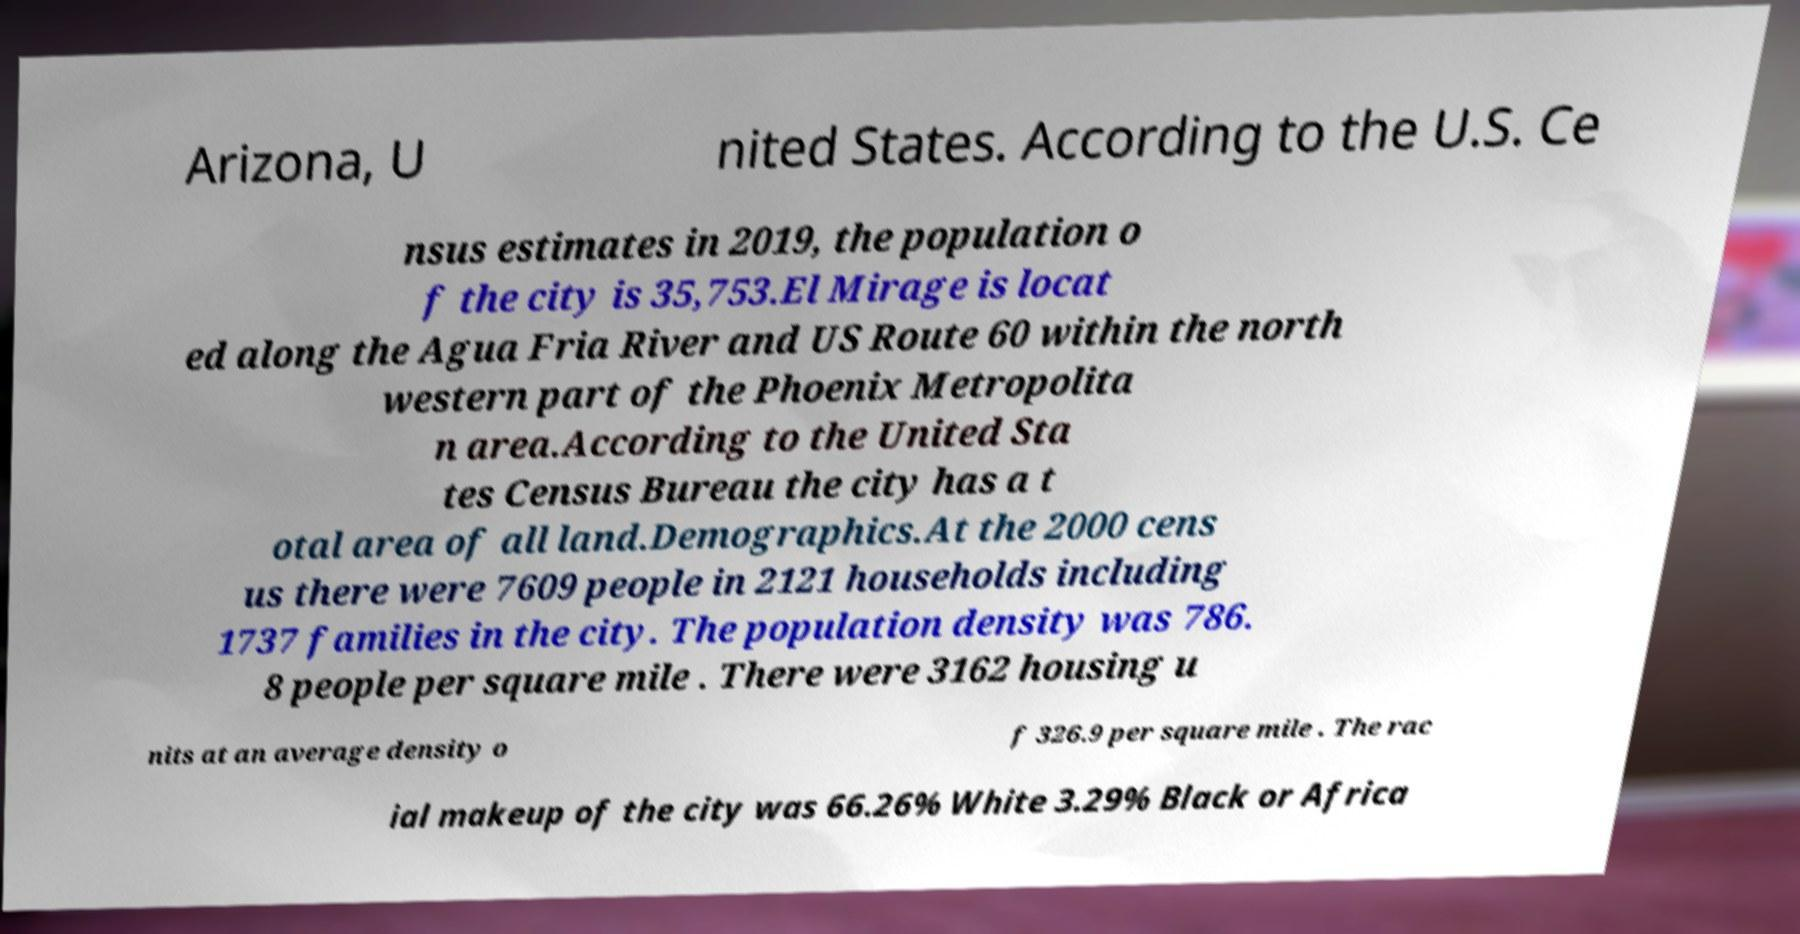Please read and relay the text visible in this image. What does it say? Arizona, U nited States. According to the U.S. Ce nsus estimates in 2019, the population o f the city is 35,753.El Mirage is locat ed along the Agua Fria River and US Route 60 within the north western part of the Phoenix Metropolita n area.According to the United Sta tes Census Bureau the city has a t otal area of all land.Demographics.At the 2000 cens us there were 7609 people in 2121 households including 1737 families in the city. The population density was 786. 8 people per square mile . There were 3162 housing u nits at an average density o f 326.9 per square mile . The rac ial makeup of the city was 66.26% White 3.29% Black or Africa 